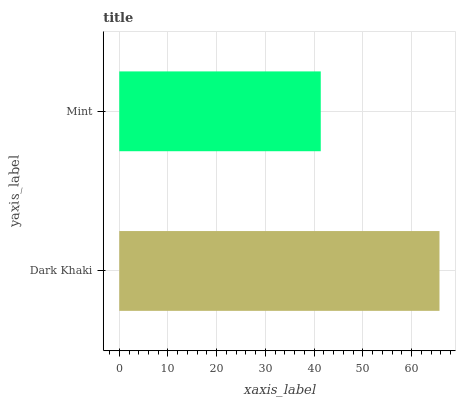Is Mint the minimum?
Answer yes or no. Yes. Is Dark Khaki the maximum?
Answer yes or no. Yes. Is Mint the maximum?
Answer yes or no. No. Is Dark Khaki greater than Mint?
Answer yes or no. Yes. Is Mint less than Dark Khaki?
Answer yes or no. Yes. Is Mint greater than Dark Khaki?
Answer yes or no. No. Is Dark Khaki less than Mint?
Answer yes or no. No. Is Dark Khaki the high median?
Answer yes or no. Yes. Is Mint the low median?
Answer yes or no. Yes. Is Mint the high median?
Answer yes or no. No. Is Dark Khaki the low median?
Answer yes or no. No. 